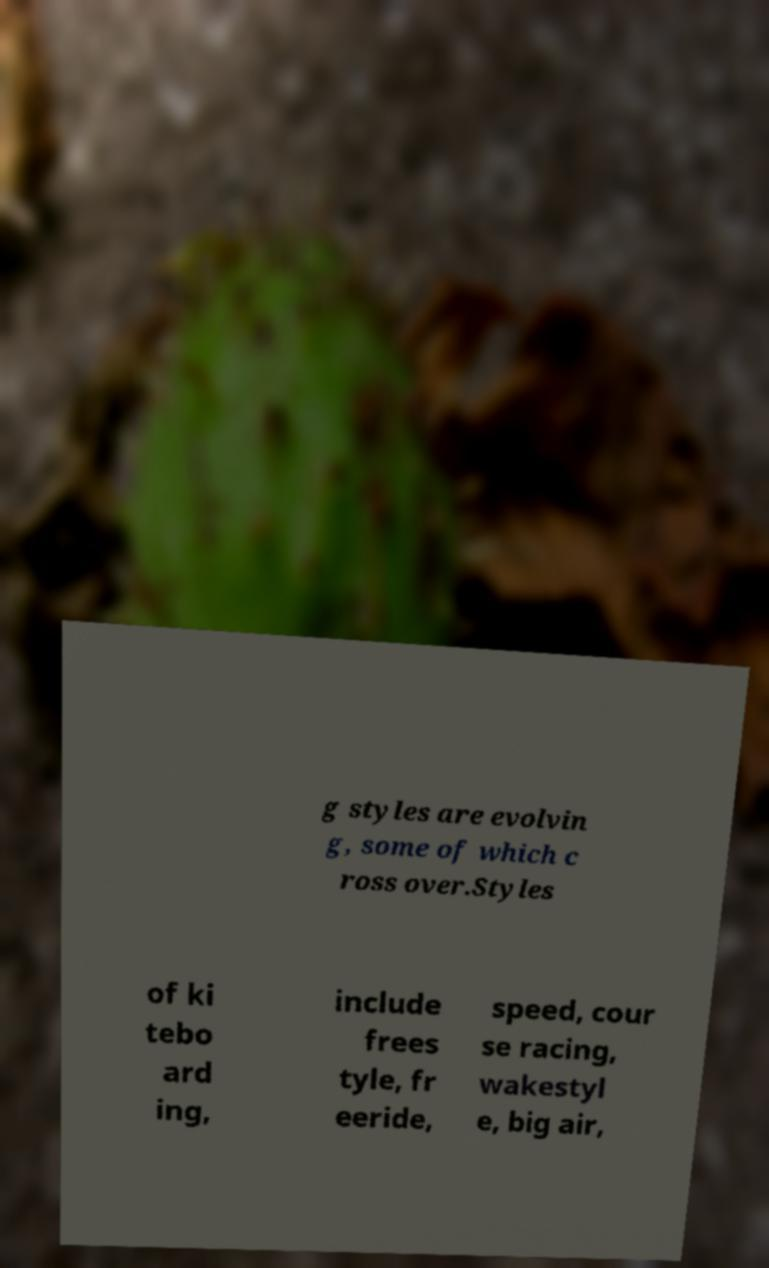Please identify and transcribe the text found in this image. g styles are evolvin g, some of which c ross over.Styles of ki tebo ard ing, include frees tyle, fr eeride, speed, cour se racing, wakestyl e, big air, 